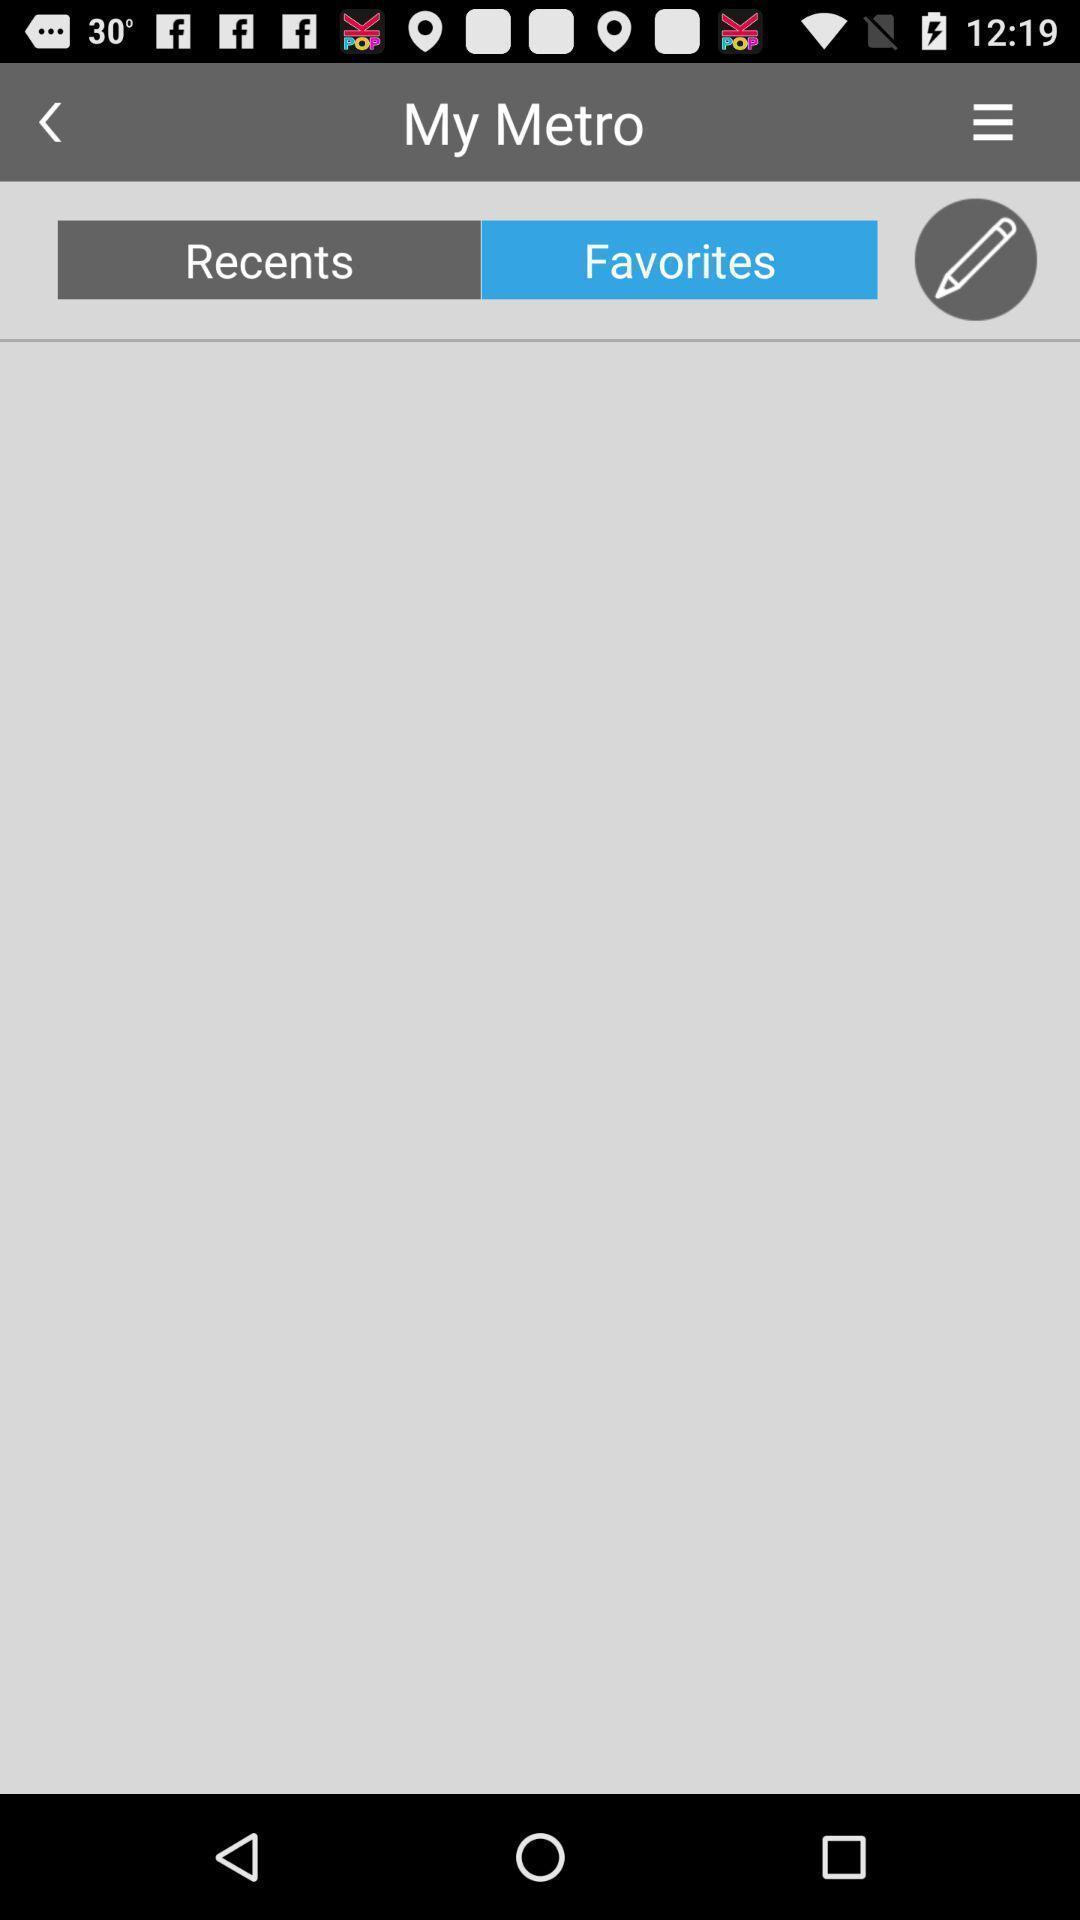Provide a detailed account of this screenshot. Page showing metro with other options in travel app. 